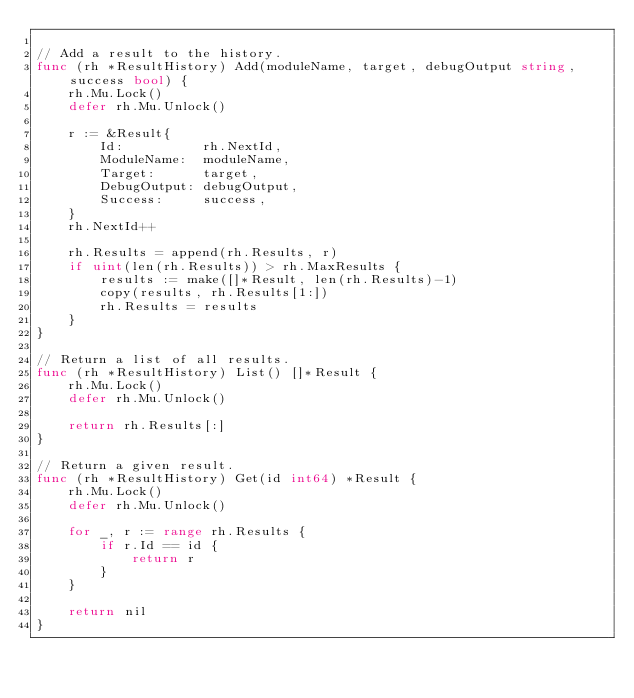Convert code to text. <code><loc_0><loc_0><loc_500><loc_500><_Go_>
// Add a result to the history.
func (rh *ResultHistory) Add(moduleName, target, debugOutput string, success bool) {
	rh.Mu.Lock()
	defer rh.Mu.Unlock()

	r := &Result{
		Id:          rh.NextId,
		ModuleName:  moduleName,
		Target:      target,
		DebugOutput: debugOutput,
		Success:     success,
	}
	rh.NextId++

	rh.Results = append(rh.Results, r)
	if uint(len(rh.Results)) > rh.MaxResults {
		results := make([]*Result, len(rh.Results)-1)
		copy(results, rh.Results[1:])
		rh.Results = results
	}
}

// Return a list of all results.
func (rh *ResultHistory) List() []*Result {
	rh.Mu.Lock()
	defer rh.Mu.Unlock()

	return rh.Results[:]
}

// Return a given result.
func (rh *ResultHistory) Get(id int64) *Result {
	rh.Mu.Lock()
	defer rh.Mu.Unlock()

	for _, r := range rh.Results {
		if r.Id == id {
			return r
		}
	}

	return nil
}
</code> 